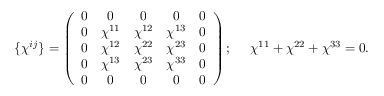Convert formula to latex. <formula><loc_0><loc_0><loc_500><loc_500>\{ \chi ^ { i j } \} = \left ( \begin{array} { c c c c c } { 0 } & { 0 } & { 0 } & { 0 } & { 0 } \\ { 0 } & { { \chi ^ { 1 1 } } } & { { \chi ^ { 1 2 } } } & { { \chi ^ { 1 3 } } } & { 0 } \\ { 0 } & { { \chi ^ { 1 2 } } } & { { \chi ^ { 2 2 } } } & { { \chi ^ { 2 3 } } } & { 0 } \\ { 0 } & { { \chi ^ { 1 3 } } } & { { \chi ^ { 2 3 } } } & { { \chi ^ { 3 3 } } } & { 0 } \\ { 0 } & { 0 } & { 0 } & { 0 } & { 0 } \end{array} \right ) ; \chi ^ { 1 1 } + \chi ^ { 2 2 } + \chi ^ { 3 3 } = 0 .</formula> 